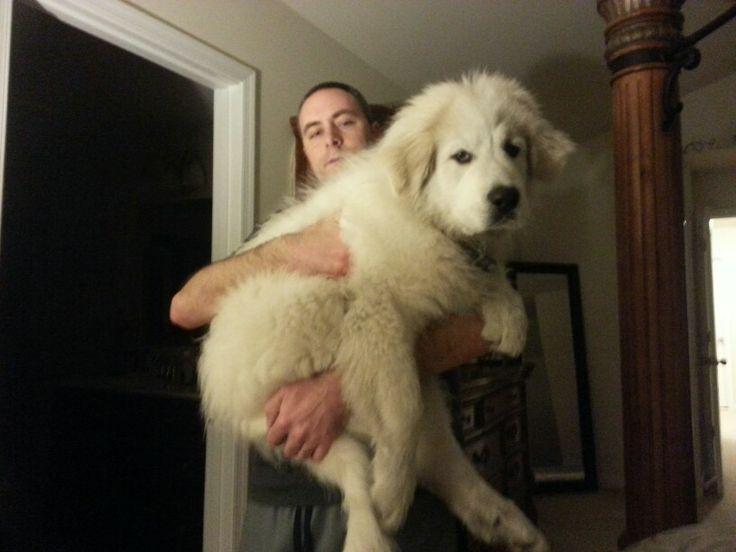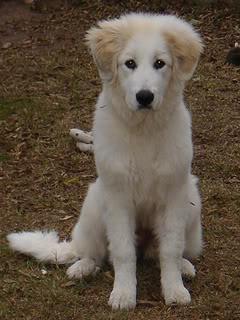The first image is the image on the left, the second image is the image on the right. Considering the images on both sides, is "in both pairs the dogs are on a natural outdoor surface" valid? Answer yes or no. No. 